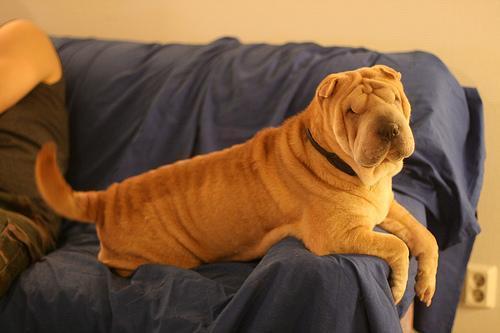How many dogs are there?
Give a very brief answer. 1. 